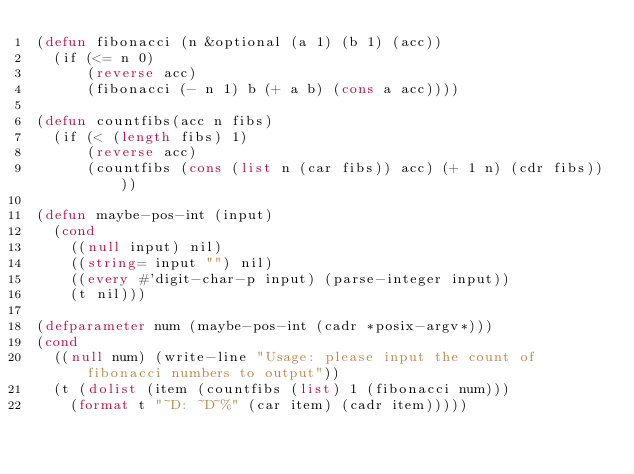<code> <loc_0><loc_0><loc_500><loc_500><_Lisp_>(defun fibonacci (n &optional (a 1) (b 1) (acc))
  (if (<= n 0)
      (reverse acc)
      (fibonacci (- n 1) b (+ a b) (cons a acc))))

(defun countfibs(acc n fibs)
  (if (< (length fibs) 1)
      (reverse acc)
      (countfibs (cons (list n (car fibs)) acc) (+ 1 n) (cdr fibs))))

(defun maybe-pos-int (input)
  (cond
    ((null input) nil)
    ((string= input "") nil)
    ((every #'digit-char-p input) (parse-integer input))
    (t nil)))

(defparameter num (maybe-pos-int (cadr *posix-argv*)))
(cond
  ((null num) (write-line "Usage: please input the count of fibonacci numbers to output"))
  (t (dolist (item (countfibs (list) 1 (fibonacci num)))
    (format t "~D: ~D~%" (car item) (cadr item)))))
</code> 